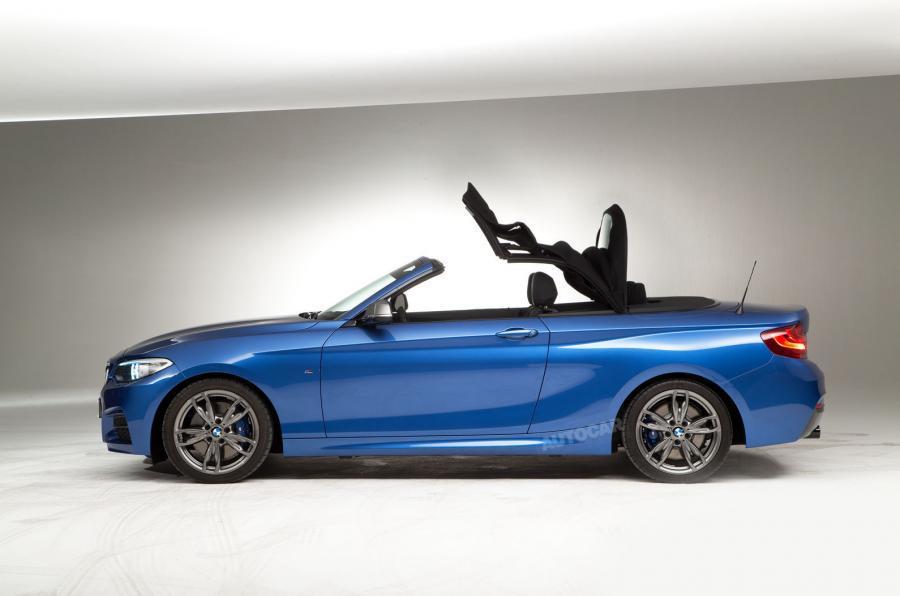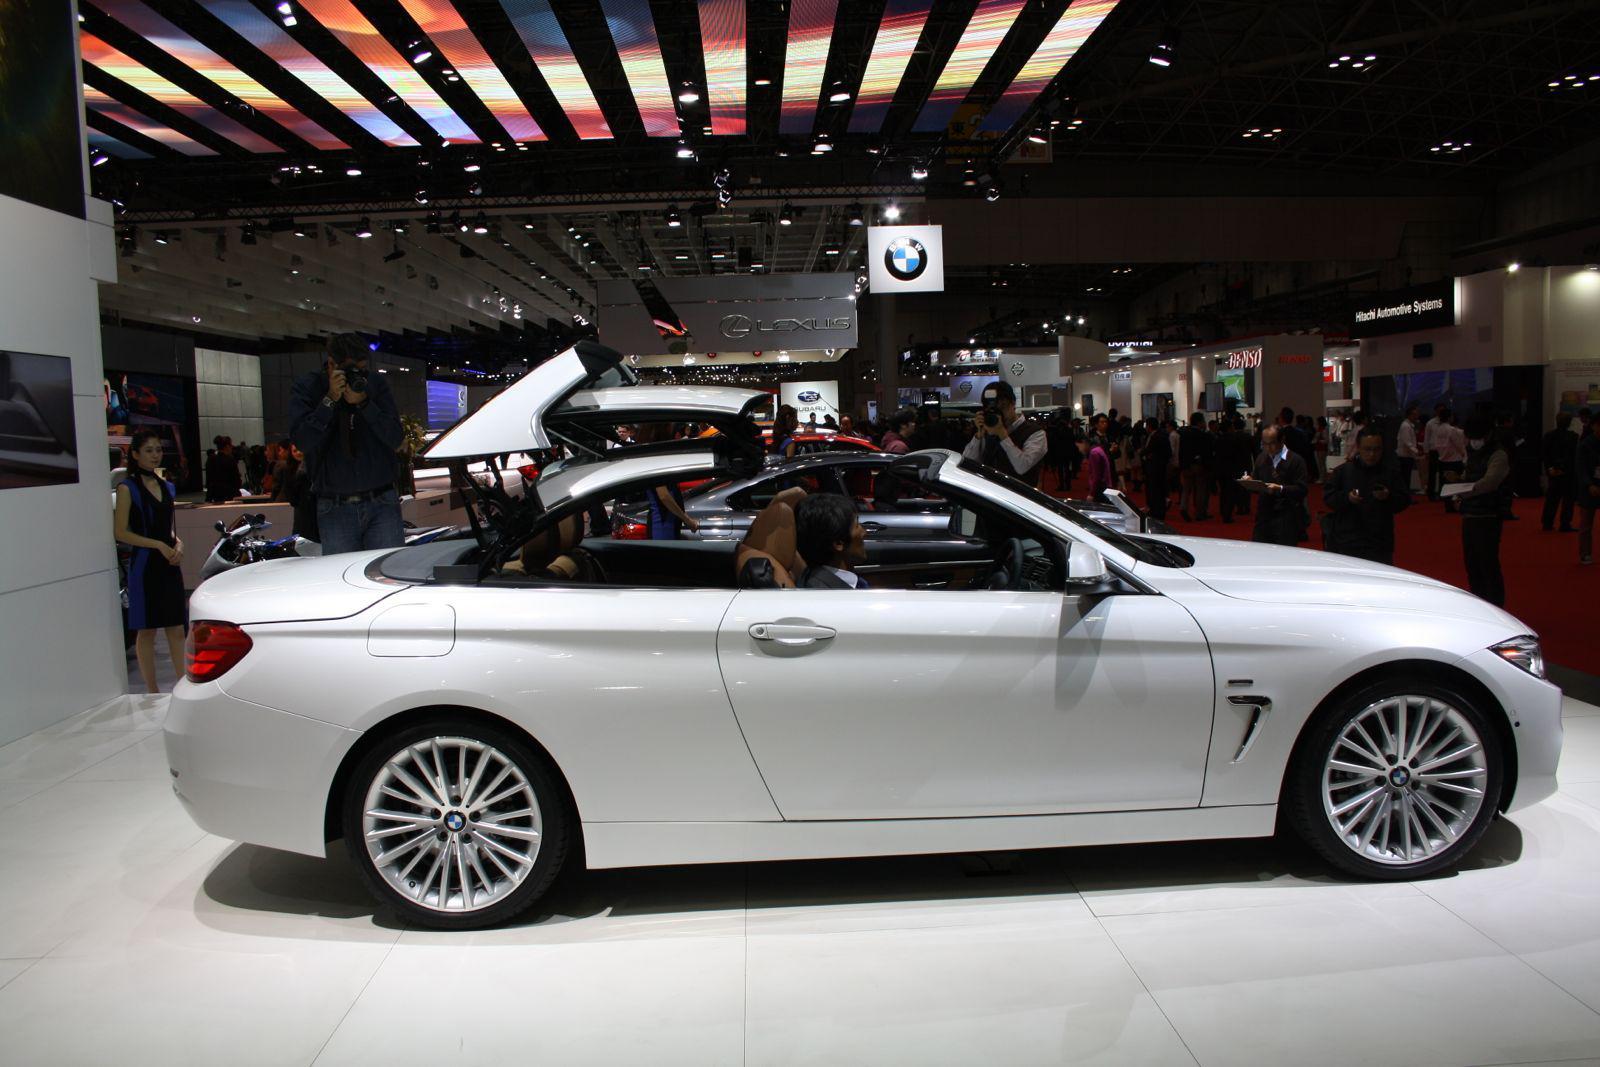The first image is the image on the left, the second image is the image on the right. Analyze the images presented: Is the assertion "The right image contains at least one red sports car." valid? Answer yes or no. No. The first image is the image on the left, the second image is the image on the right. Given the left and right images, does the statement "Right and left images each contain a convertible in side view with its top partly raised." hold true? Answer yes or no. Yes. 